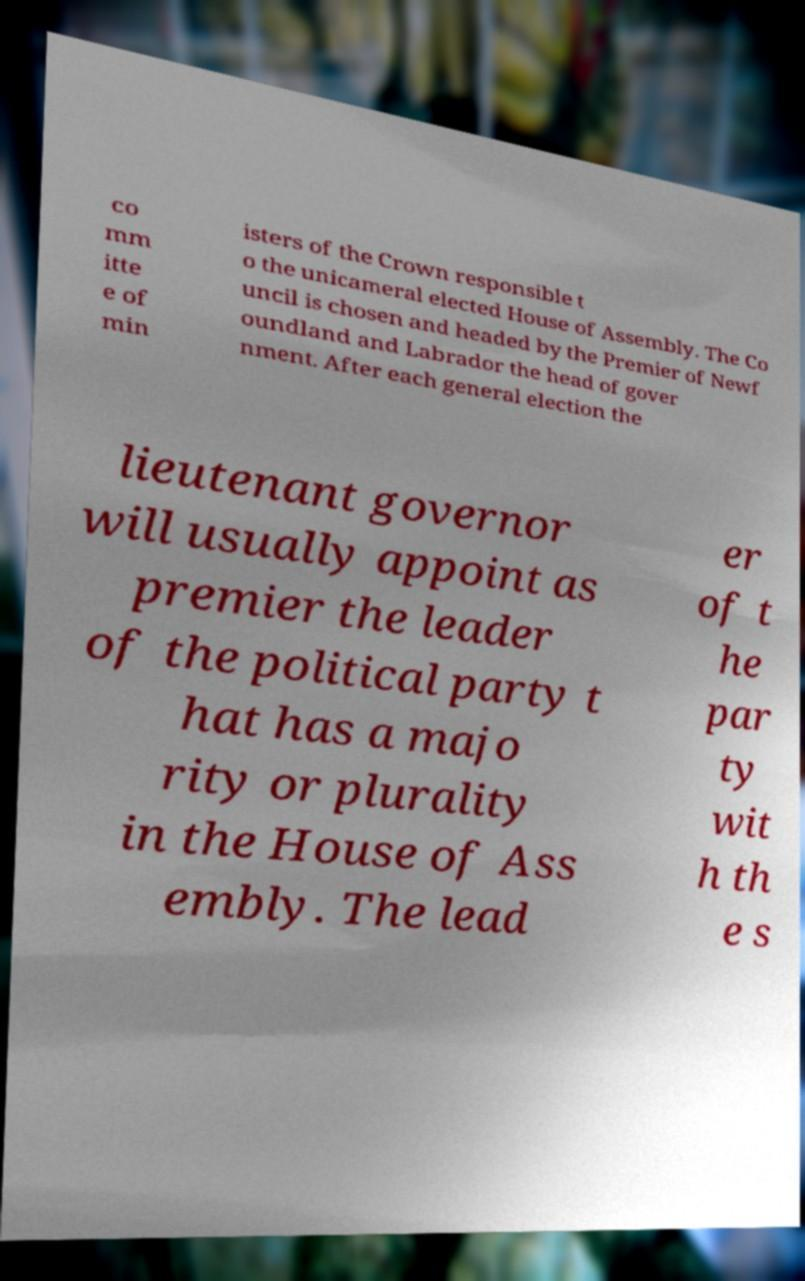Can you accurately transcribe the text from the provided image for me? co mm itte e of min isters of the Crown responsible t o the unicameral elected House of Assembly. The Co uncil is chosen and headed by the Premier of Newf oundland and Labrador the head of gover nment. After each general election the lieutenant governor will usually appoint as premier the leader of the political party t hat has a majo rity or plurality in the House of Ass embly. The lead er of t he par ty wit h th e s 